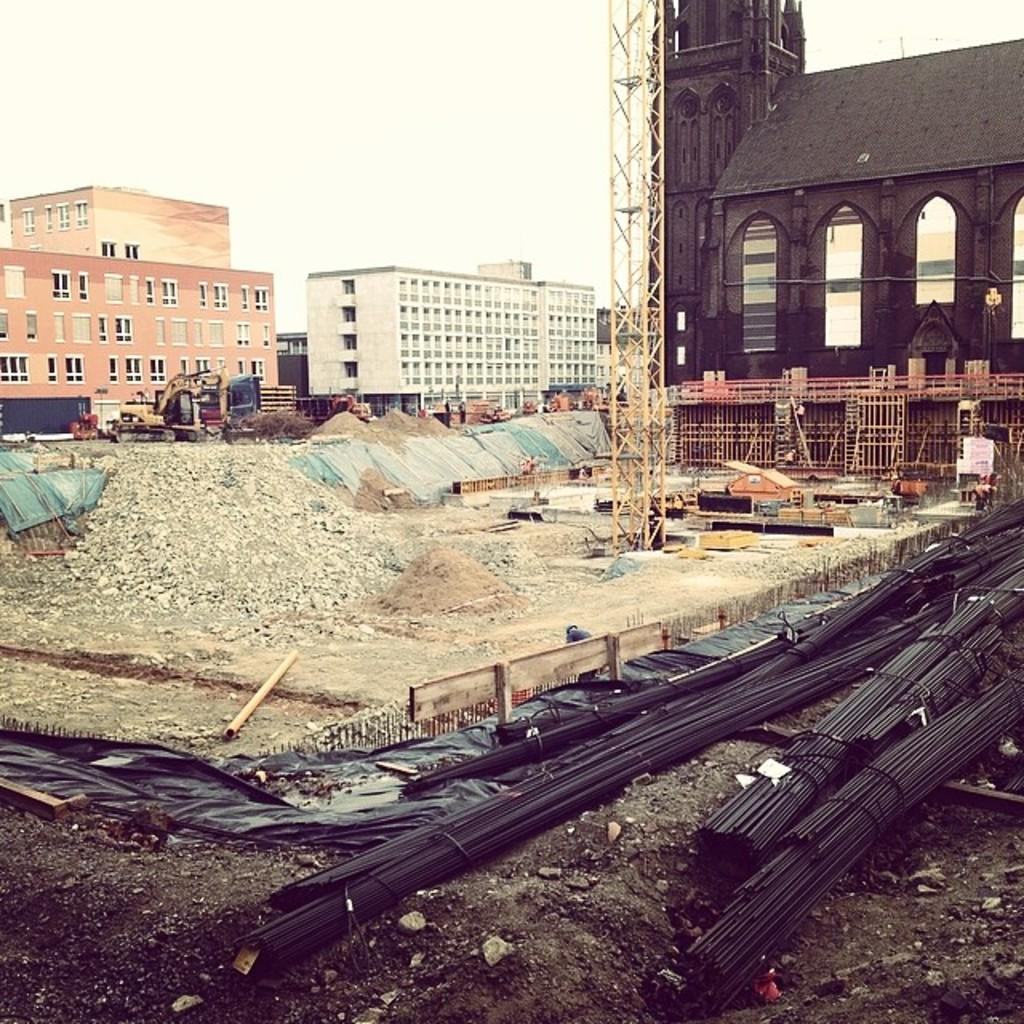What materials are present in the image? There are rods, wooden planks, stones, and sheets in the image. What type of surface is visible in the image? There is sand in the image. What is the primary mode of transportation in the image? There is a vehicle in the image. What other objects can be seen in the image? There are other objects in the image, but their specific nature is not mentioned in the facts. What can be seen in the background of the image? There are buildings and sky visible in the background of the image. What type of noise can be heard coming from the stew in the image? There is no stew present in the image, so it is not possible to determine what, if any, noise might be heard. 